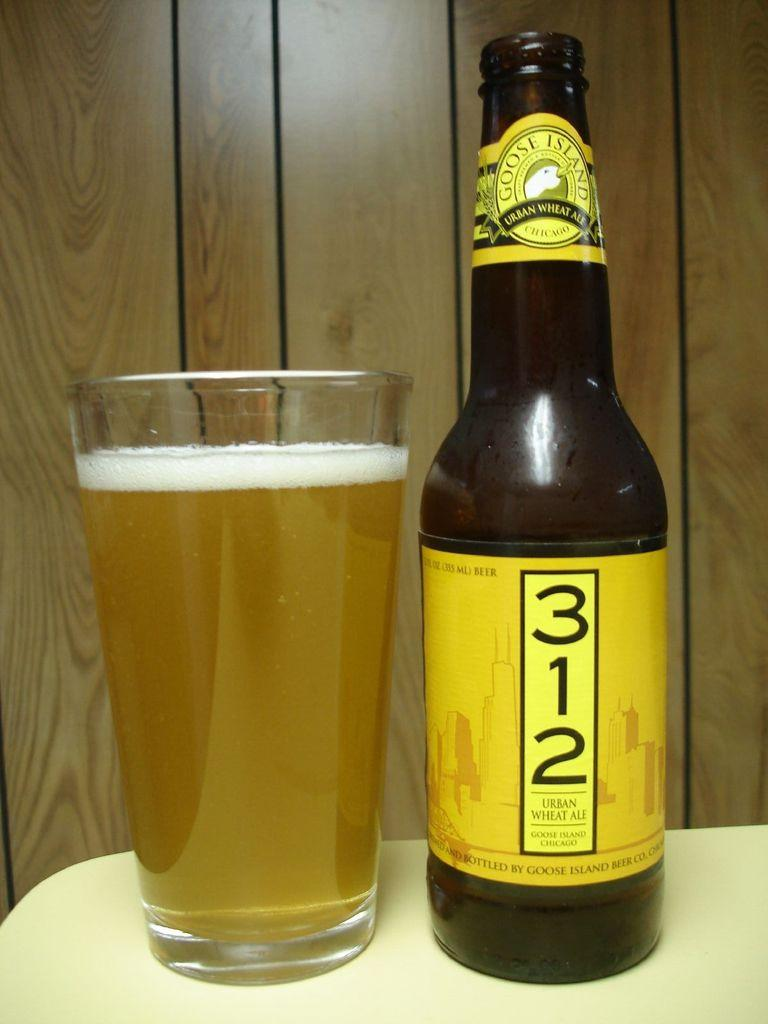<image>
Relay a brief, clear account of the picture shown. A 312 beer bottle is next to a full glass of beer. 